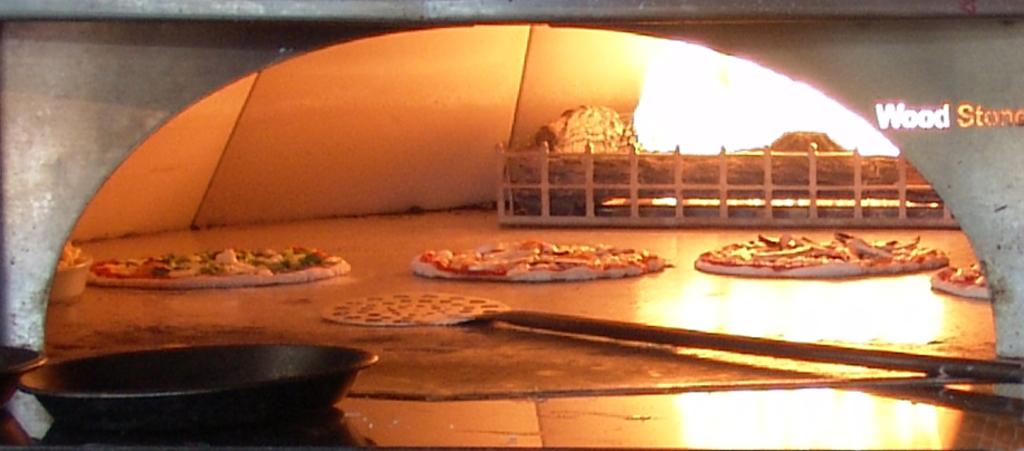How are these pizza's being cooked?
Provide a succinct answer. Wood stove. What word is on the top right?
Ensure brevity in your answer.  Wood stone. 